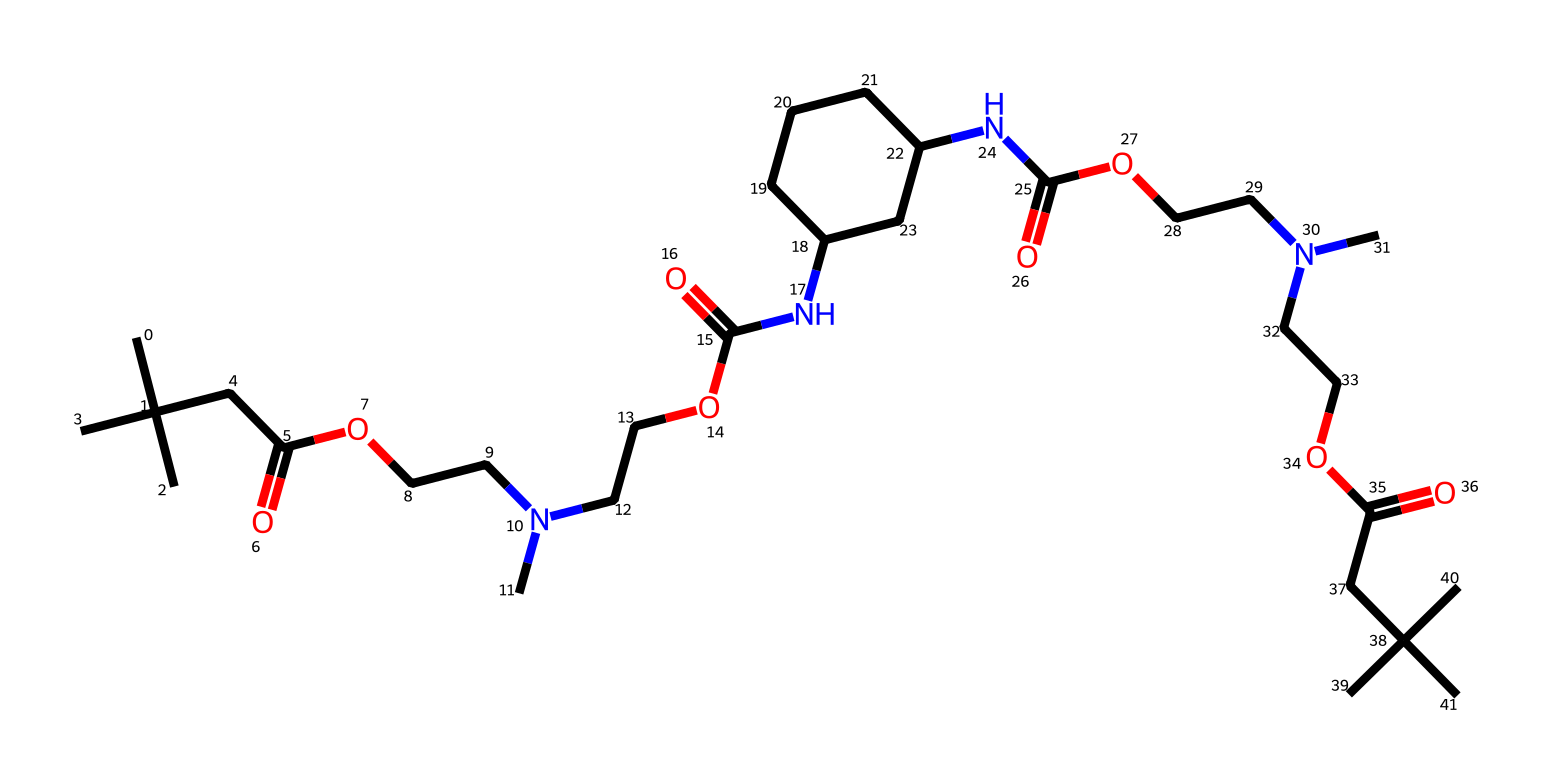What is the molecular formula represented by the SMILES? The provided SMILES indicates the presence of specific atoms in the structure. Counting the carbon (C), hydrogen (H), nitrogen (N), and oxygen (O) atoms gives us the molecular formula C23H44N4O6.
Answer: C23H44N4O6 How many nitrogen atoms are in the chemical structure? By interpreting the SMILES representation, we can identify that there are four instances of nitrogen (N) within the formula.
Answer: 4 What type of polymer is represented by this chemical? The presence of repeating urethane linkages (NH-CO-O) suggests that this chemical is a polyurethane-type polymer.
Answer: polyurethane How many ester groups are present in this structure? Each occurrence of the -COO- (ester functional group) can be traced in the SMILES. Counting these gives a total of four ester groups present.
Answer: 4 Which functional groups are dominant in this polymer? The polymer has a combination of amine (NH), amide (C(=O)N), and ester (C(=O)O) functional groups, making those the dominant ones observed.
Answer: amine, amide, ester What is the significance of the branched alkyl groups in the structure? The branched alkyl groups enhance the physical properties of the polyurethane foam, specifically providing increased flexibility and impact resistance, which is crucial for boxing gloves.
Answer: flexibility and impact resistance 